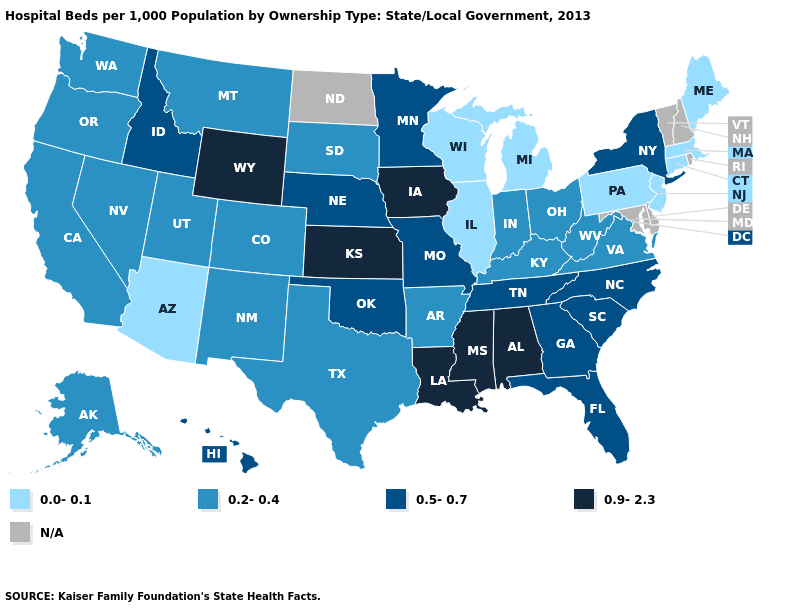Does the map have missing data?
Write a very short answer. Yes. Does Connecticut have the lowest value in the Northeast?
Short answer required. Yes. What is the value of Idaho?
Concise answer only. 0.5-0.7. What is the lowest value in states that border Connecticut?
Answer briefly. 0.0-0.1. What is the value of Idaho?
Quick response, please. 0.5-0.7. Does the first symbol in the legend represent the smallest category?
Quick response, please. Yes. Which states hav the highest value in the South?
Write a very short answer. Alabama, Louisiana, Mississippi. What is the highest value in the South ?
Write a very short answer. 0.9-2.3. Does Arizona have the lowest value in the USA?
Write a very short answer. Yes. Name the states that have a value in the range 0.5-0.7?
Write a very short answer. Florida, Georgia, Hawaii, Idaho, Minnesota, Missouri, Nebraska, New York, North Carolina, Oklahoma, South Carolina, Tennessee. Among the states that border Oregon , which have the lowest value?
Keep it brief. California, Nevada, Washington. Name the states that have a value in the range N/A?
Write a very short answer. Delaware, Maryland, New Hampshire, North Dakota, Rhode Island, Vermont. Which states have the lowest value in the South?
Quick response, please. Arkansas, Kentucky, Texas, Virginia, West Virginia. Name the states that have a value in the range N/A?
Answer briefly. Delaware, Maryland, New Hampshire, North Dakota, Rhode Island, Vermont. 